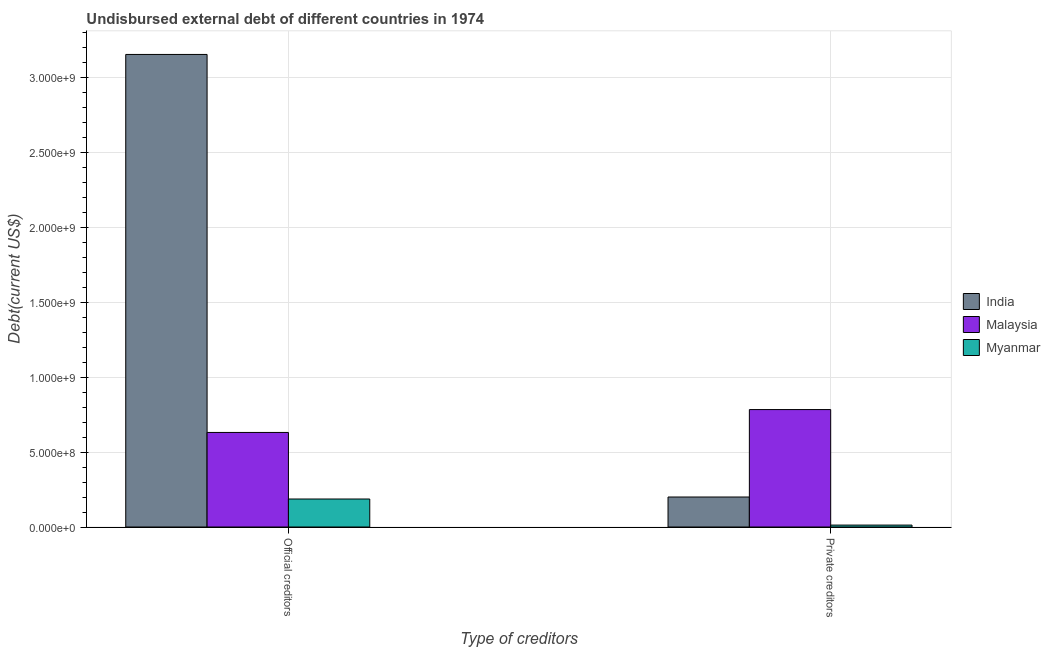Are the number of bars per tick equal to the number of legend labels?
Provide a succinct answer. Yes. What is the label of the 2nd group of bars from the left?
Offer a terse response. Private creditors. What is the undisbursed external debt of private creditors in India?
Your answer should be compact. 2.00e+08. Across all countries, what is the maximum undisbursed external debt of private creditors?
Give a very brief answer. 7.83e+08. Across all countries, what is the minimum undisbursed external debt of private creditors?
Your answer should be very brief. 1.28e+07. In which country was the undisbursed external debt of private creditors maximum?
Ensure brevity in your answer.  Malaysia. In which country was the undisbursed external debt of private creditors minimum?
Give a very brief answer. Myanmar. What is the total undisbursed external debt of private creditors in the graph?
Provide a succinct answer. 9.96e+08. What is the difference between the undisbursed external debt of official creditors in India and that in Malaysia?
Your answer should be very brief. 2.52e+09. What is the difference between the undisbursed external debt of private creditors in India and the undisbursed external debt of official creditors in Malaysia?
Give a very brief answer. -4.31e+08. What is the average undisbursed external debt of private creditors per country?
Keep it short and to the point. 3.32e+08. What is the difference between the undisbursed external debt of official creditors and undisbursed external debt of private creditors in India?
Ensure brevity in your answer.  2.95e+09. In how many countries, is the undisbursed external debt of private creditors greater than 2400000000 US$?
Your response must be concise. 0. What is the ratio of the undisbursed external debt of official creditors in Myanmar to that in India?
Provide a succinct answer. 0.06. Is the undisbursed external debt of official creditors in Malaysia less than that in Myanmar?
Ensure brevity in your answer.  No. What does the 3rd bar from the left in Official creditors represents?
Offer a terse response. Myanmar. What does the 1st bar from the right in Private creditors represents?
Provide a succinct answer. Myanmar. How many bars are there?
Your response must be concise. 6. Are all the bars in the graph horizontal?
Offer a terse response. No. How many countries are there in the graph?
Keep it short and to the point. 3. What is the difference between two consecutive major ticks on the Y-axis?
Provide a short and direct response. 5.00e+08. Does the graph contain any zero values?
Give a very brief answer. No. Where does the legend appear in the graph?
Offer a terse response. Center right. How many legend labels are there?
Ensure brevity in your answer.  3. How are the legend labels stacked?
Offer a terse response. Vertical. What is the title of the graph?
Your answer should be compact. Undisbursed external debt of different countries in 1974. Does "Dominican Republic" appear as one of the legend labels in the graph?
Provide a succinct answer. No. What is the label or title of the X-axis?
Provide a short and direct response. Type of creditors. What is the label or title of the Y-axis?
Your answer should be very brief. Debt(current US$). What is the Debt(current US$) in India in Official creditors?
Provide a short and direct response. 3.15e+09. What is the Debt(current US$) of Malaysia in Official creditors?
Make the answer very short. 6.31e+08. What is the Debt(current US$) in Myanmar in Official creditors?
Your response must be concise. 1.87e+08. What is the Debt(current US$) in India in Private creditors?
Give a very brief answer. 2.00e+08. What is the Debt(current US$) in Malaysia in Private creditors?
Provide a succinct answer. 7.83e+08. What is the Debt(current US$) of Myanmar in Private creditors?
Your response must be concise. 1.28e+07. Across all Type of creditors, what is the maximum Debt(current US$) in India?
Make the answer very short. 3.15e+09. Across all Type of creditors, what is the maximum Debt(current US$) of Malaysia?
Make the answer very short. 7.83e+08. Across all Type of creditors, what is the maximum Debt(current US$) in Myanmar?
Your answer should be very brief. 1.87e+08. Across all Type of creditors, what is the minimum Debt(current US$) in India?
Offer a terse response. 2.00e+08. Across all Type of creditors, what is the minimum Debt(current US$) of Malaysia?
Keep it short and to the point. 6.31e+08. Across all Type of creditors, what is the minimum Debt(current US$) of Myanmar?
Offer a very short reply. 1.28e+07. What is the total Debt(current US$) of India in the graph?
Your answer should be very brief. 3.35e+09. What is the total Debt(current US$) in Malaysia in the graph?
Offer a terse response. 1.41e+09. What is the total Debt(current US$) of Myanmar in the graph?
Your response must be concise. 2.00e+08. What is the difference between the Debt(current US$) of India in Official creditors and that in Private creditors?
Provide a short and direct response. 2.95e+09. What is the difference between the Debt(current US$) in Malaysia in Official creditors and that in Private creditors?
Provide a succinct answer. -1.53e+08. What is the difference between the Debt(current US$) in Myanmar in Official creditors and that in Private creditors?
Make the answer very short. 1.74e+08. What is the difference between the Debt(current US$) in India in Official creditors and the Debt(current US$) in Malaysia in Private creditors?
Offer a terse response. 2.37e+09. What is the difference between the Debt(current US$) of India in Official creditors and the Debt(current US$) of Myanmar in Private creditors?
Your answer should be compact. 3.14e+09. What is the difference between the Debt(current US$) of Malaysia in Official creditors and the Debt(current US$) of Myanmar in Private creditors?
Your answer should be compact. 6.18e+08. What is the average Debt(current US$) of India per Type of creditors?
Keep it short and to the point. 1.68e+09. What is the average Debt(current US$) of Malaysia per Type of creditors?
Offer a very short reply. 7.07e+08. What is the average Debt(current US$) of Myanmar per Type of creditors?
Your response must be concise. 9.98e+07. What is the difference between the Debt(current US$) of India and Debt(current US$) of Malaysia in Official creditors?
Provide a succinct answer. 2.52e+09. What is the difference between the Debt(current US$) of India and Debt(current US$) of Myanmar in Official creditors?
Your answer should be compact. 2.97e+09. What is the difference between the Debt(current US$) in Malaysia and Debt(current US$) in Myanmar in Official creditors?
Make the answer very short. 4.44e+08. What is the difference between the Debt(current US$) in India and Debt(current US$) in Malaysia in Private creditors?
Make the answer very short. -5.83e+08. What is the difference between the Debt(current US$) of India and Debt(current US$) of Myanmar in Private creditors?
Offer a very short reply. 1.87e+08. What is the difference between the Debt(current US$) in Malaysia and Debt(current US$) in Myanmar in Private creditors?
Your response must be concise. 7.71e+08. What is the ratio of the Debt(current US$) of India in Official creditors to that in Private creditors?
Provide a short and direct response. 15.75. What is the ratio of the Debt(current US$) of Malaysia in Official creditors to that in Private creditors?
Give a very brief answer. 0.81. What is the ratio of the Debt(current US$) in Myanmar in Official creditors to that in Private creditors?
Keep it short and to the point. 14.56. What is the difference between the highest and the second highest Debt(current US$) in India?
Your answer should be very brief. 2.95e+09. What is the difference between the highest and the second highest Debt(current US$) in Malaysia?
Offer a very short reply. 1.53e+08. What is the difference between the highest and the second highest Debt(current US$) in Myanmar?
Ensure brevity in your answer.  1.74e+08. What is the difference between the highest and the lowest Debt(current US$) in India?
Provide a succinct answer. 2.95e+09. What is the difference between the highest and the lowest Debt(current US$) in Malaysia?
Offer a terse response. 1.53e+08. What is the difference between the highest and the lowest Debt(current US$) of Myanmar?
Your answer should be compact. 1.74e+08. 